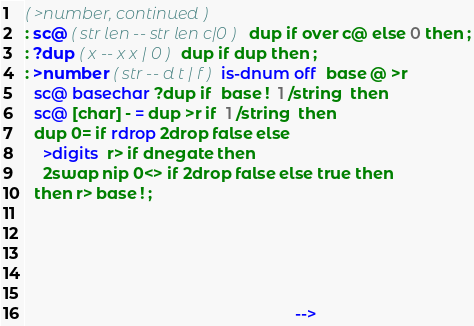Convert code to text. <code><loc_0><loc_0><loc_500><loc_500><_Forth_>( >number, continued )
: sc@ ( str len -- str len c|0 ) dup if over c@ else 0 then ;
: ?dup ( x -- x x | 0 ) dup if dup then ;
: >number ( str -- d t | f ) is-dnum off  base @ >r
  sc@ basechar ?dup if  base !  1 /string  then
  sc@ [char] - = dup >r if  1 /string  then
  dup 0= if rdrop 2drop false else
    >digits  r> if dnegate then
    2swap nip 0<> if 2drop false else true then
  then r> base ! ;





                                                             -->
</code> 